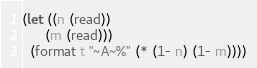<code> <loc_0><loc_0><loc_500><loc_500><_Lisp_>(let ((n (read))
      (m (read)))
  (format t "~A~%" (* (1- n) (1- m))))</code> 